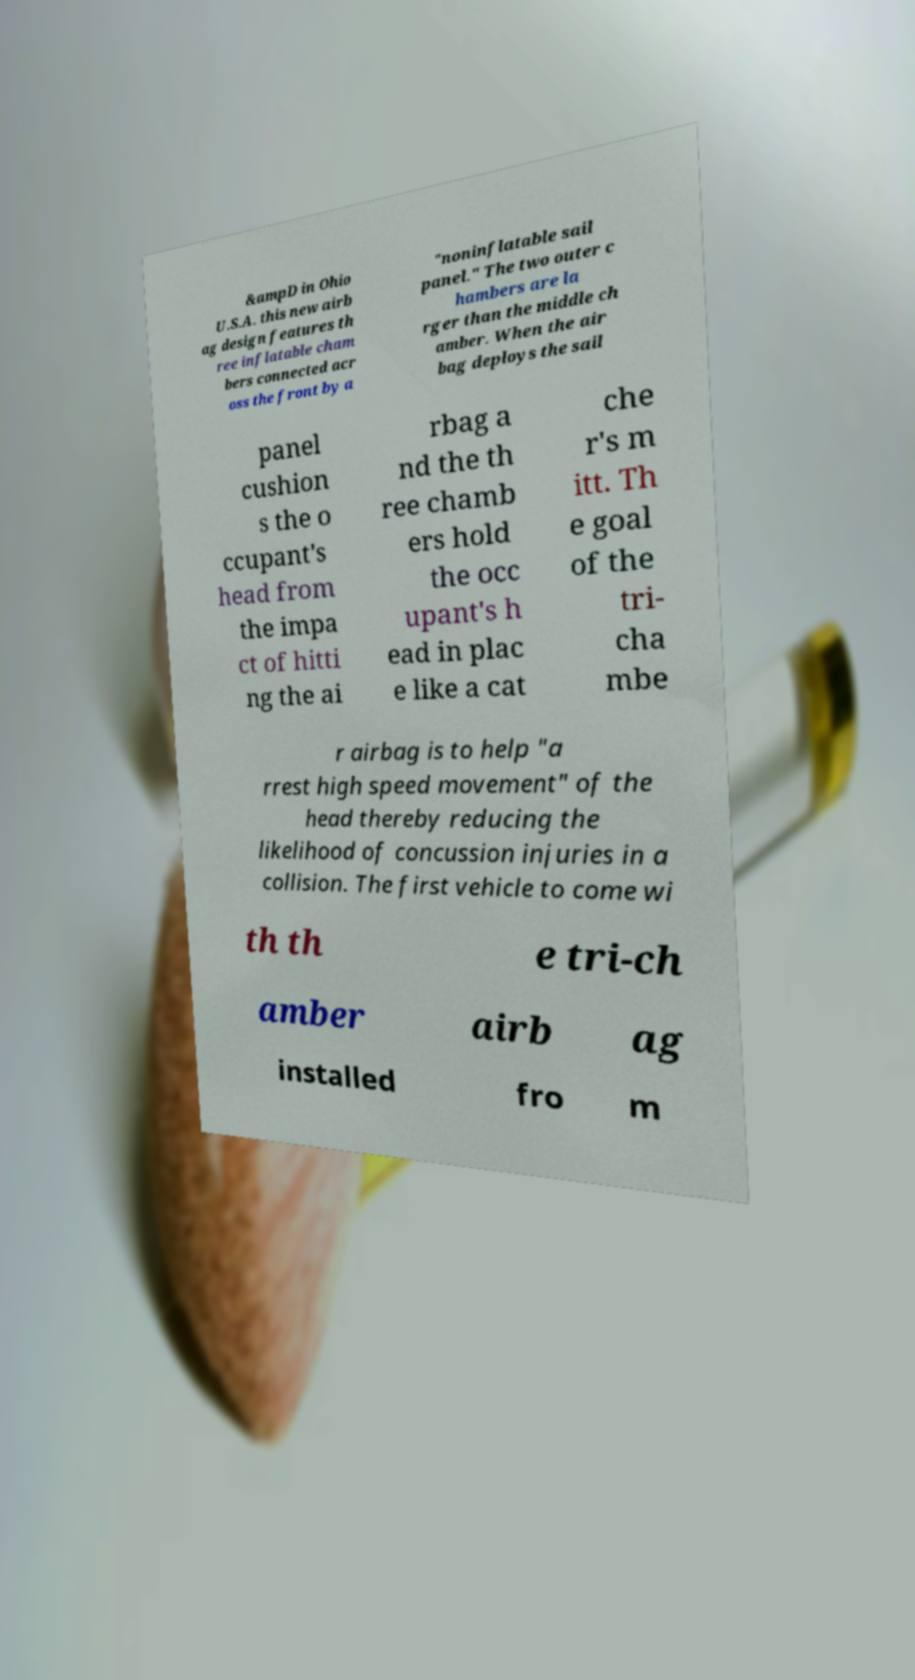I need the written content from this picture converted into text. Can you do that? &ampD in Ohio U.S.A. this new airb ag design features th ree inflatable cham bers connected acr oss the front by a "noninflatable sail panel." The two outer c hambers are la rger than the middle ch amber. When the air bag deploys the sail panel cushion s the o ccupant's head from the impa ct of hitti ng the ai rbag a nd the th ree chamb ers hold the occ upant's h ead in plac e like a cat che r's m itt. Th e goal of the tri- cha mbe r airbag is to help "a rrest high speed movement" of the head thereby reducing the likelihood of concussion injuries in a collision. The first vehicle to come wi th th e tri-ch amber airb ag installed fro m 